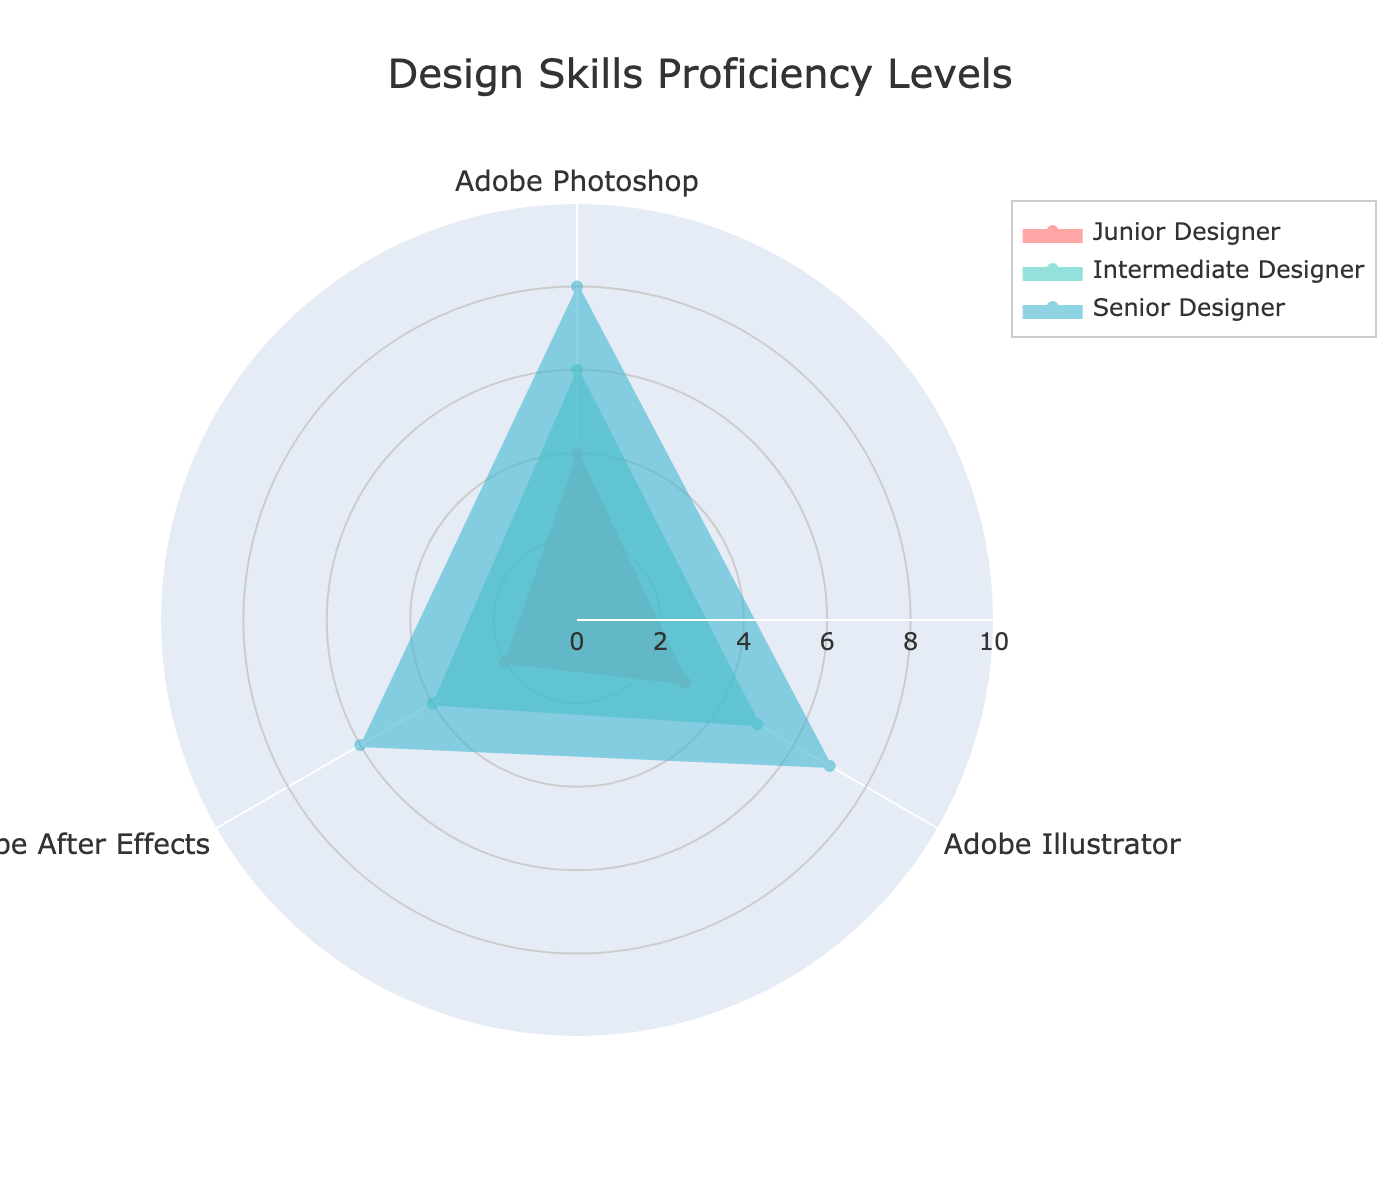What is the title of the radar chart? The title is located at the top center of the chart. It indicates the overall focus of the chart.
Answer: Design Skills Proficiency Levels Which skill does the Junior Designer have the highest proficiency in? By observing the radar plot for the Junior Designer, locate the outermost point. This corresponds to the highest proficiency score.
Answer: Adobe Photoshop By how many points does the Mentor’s proficiency in Adobe Illustrator exceed the Senior Designer’s proficiency in the same software? Check the values for the Mentor and Senior Designer for Adobe Illustrator, and then subtract the Senior Designer's value from the Mentor's value: 8 - 7 = 1.
Answer: 1 Which group is closest to the average proficiency level in Adobe After Effects? First, calculate the average proficiency level for Adobe After Effects: (2+4+6+7)/4 = 4.75. Check the group with the closest score to this average.
Answer: Intermediate Designer In which software is the difference in proficiency levels between the Junior Designer and the Senior Designer the greatest? Calculate the difference for each software: Photoshop (8-4=4), Illustrator (7-3=4), After Effects (6-2=4). The differences are equal in all three software.
Answer: All equal Which group has the highest overall proficiency across all skills? Identify the group with the highest proficiency levels in most or all of the skills. For this chart, check all values. The Mentor shows the highest levels.
Answer: Mentor How many levels higher is the Senior Designer's proficiency in Adobe After Effects compared to the Intermediate Designer? Subtract the Intermediate Designer’s proficiency level in After Effects from the Senior Designer’s: 6 - 4 = 2.
Answer: 2 What is the sum of proficiency levels across all software for the Junior Designer? Add up the proficiency levels for the Junior Designer: 4 (Photoshop) + 3 (Illustrator) + 2 (After Effects) = 9.
Answer: 9 In which skill does the Intermediate Designer show the greatest proficiency? Observe the radar point for the Intermediate Designer with the highest value: Adobe Photoshop with a score of 6.
Answer: Adobe Photoshop Who has an equal level of proficiency in Adobe Illustrator and After Effects? Check for a group where the values for both Adobe Illustrator and After Effects match. None of the groups have matching proficiency in these two skills.
Answer: None 